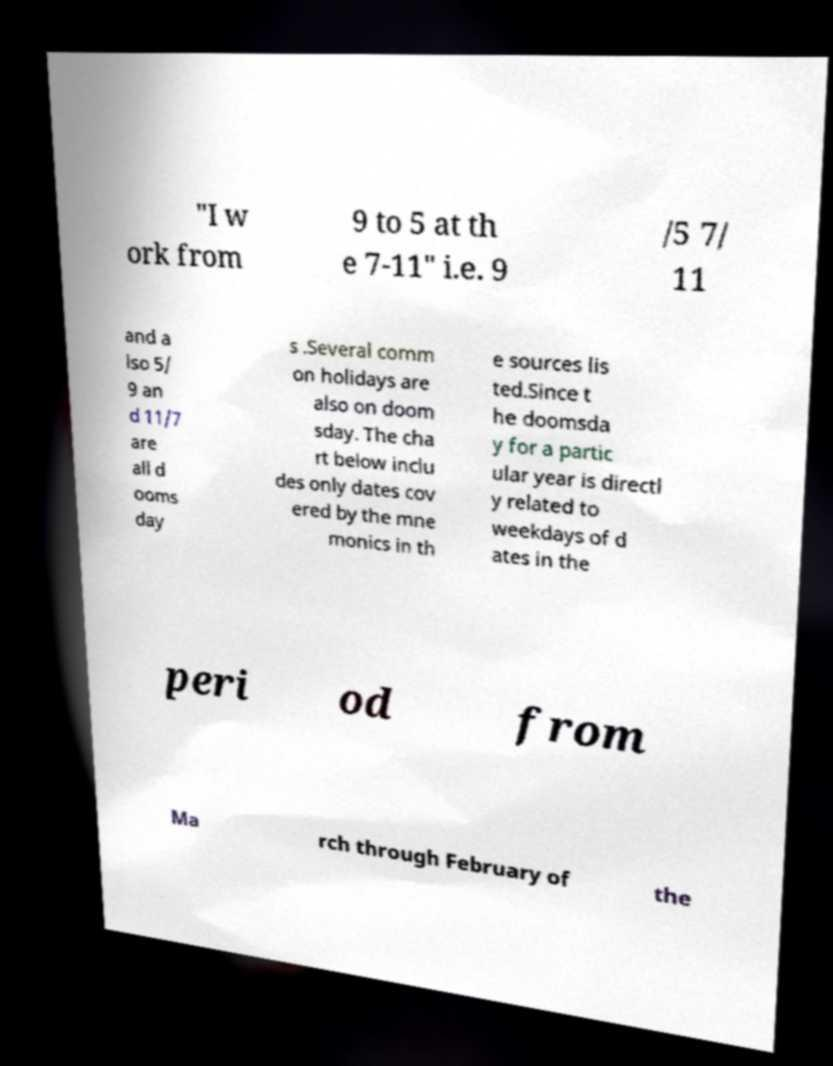Please read and relay the text visible in this image. What does it say? "I w ork from 9 to 5 at th e 7-11" i.e. 9 /5 7/ 11 and a lso 5/ 9 an d 11/7 are all d ooms day s .Several comm on holidays are also on doom sday. The cha rt below inclu des only dates cov ered by the mne monics in th e sources lis ted.Since t he doomsda y for a partic ular year is directl y related to weekdays of d ates in the peri od from Ma rch through February of the 